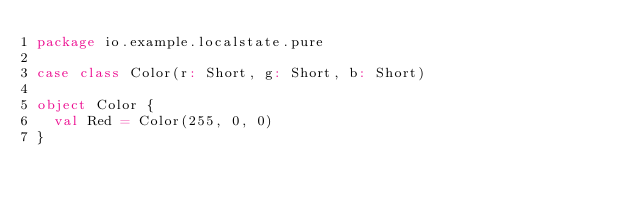<code> <loc_0><loc_0><loc_500><loc_500><_Scala_>package io.example.localstate.pure

case class Color(r: Short, g: Short, b: Short)

object Color {
  val Red = Color(255, 0, 0)
}
</code> 